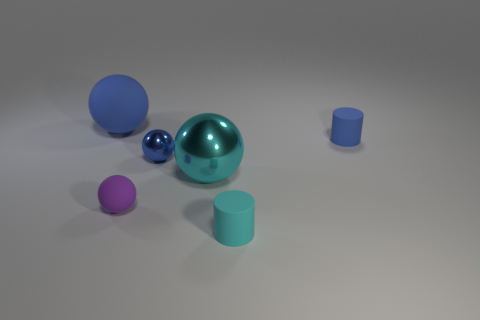Add 1 tiny metallic objects. How many objects exist? 7 Subtract all balls. How many objects are left? 2 Subtract all big metallic spheres. Subtract all large brown cylinders. How many objects are left? 5 Add 3 tiny things. How many tiny things are left? 7 Add 3 small gray objects. How many small gray objects exist? 3 Subtract 0 yellow cylinders. How many objects are left? 6 